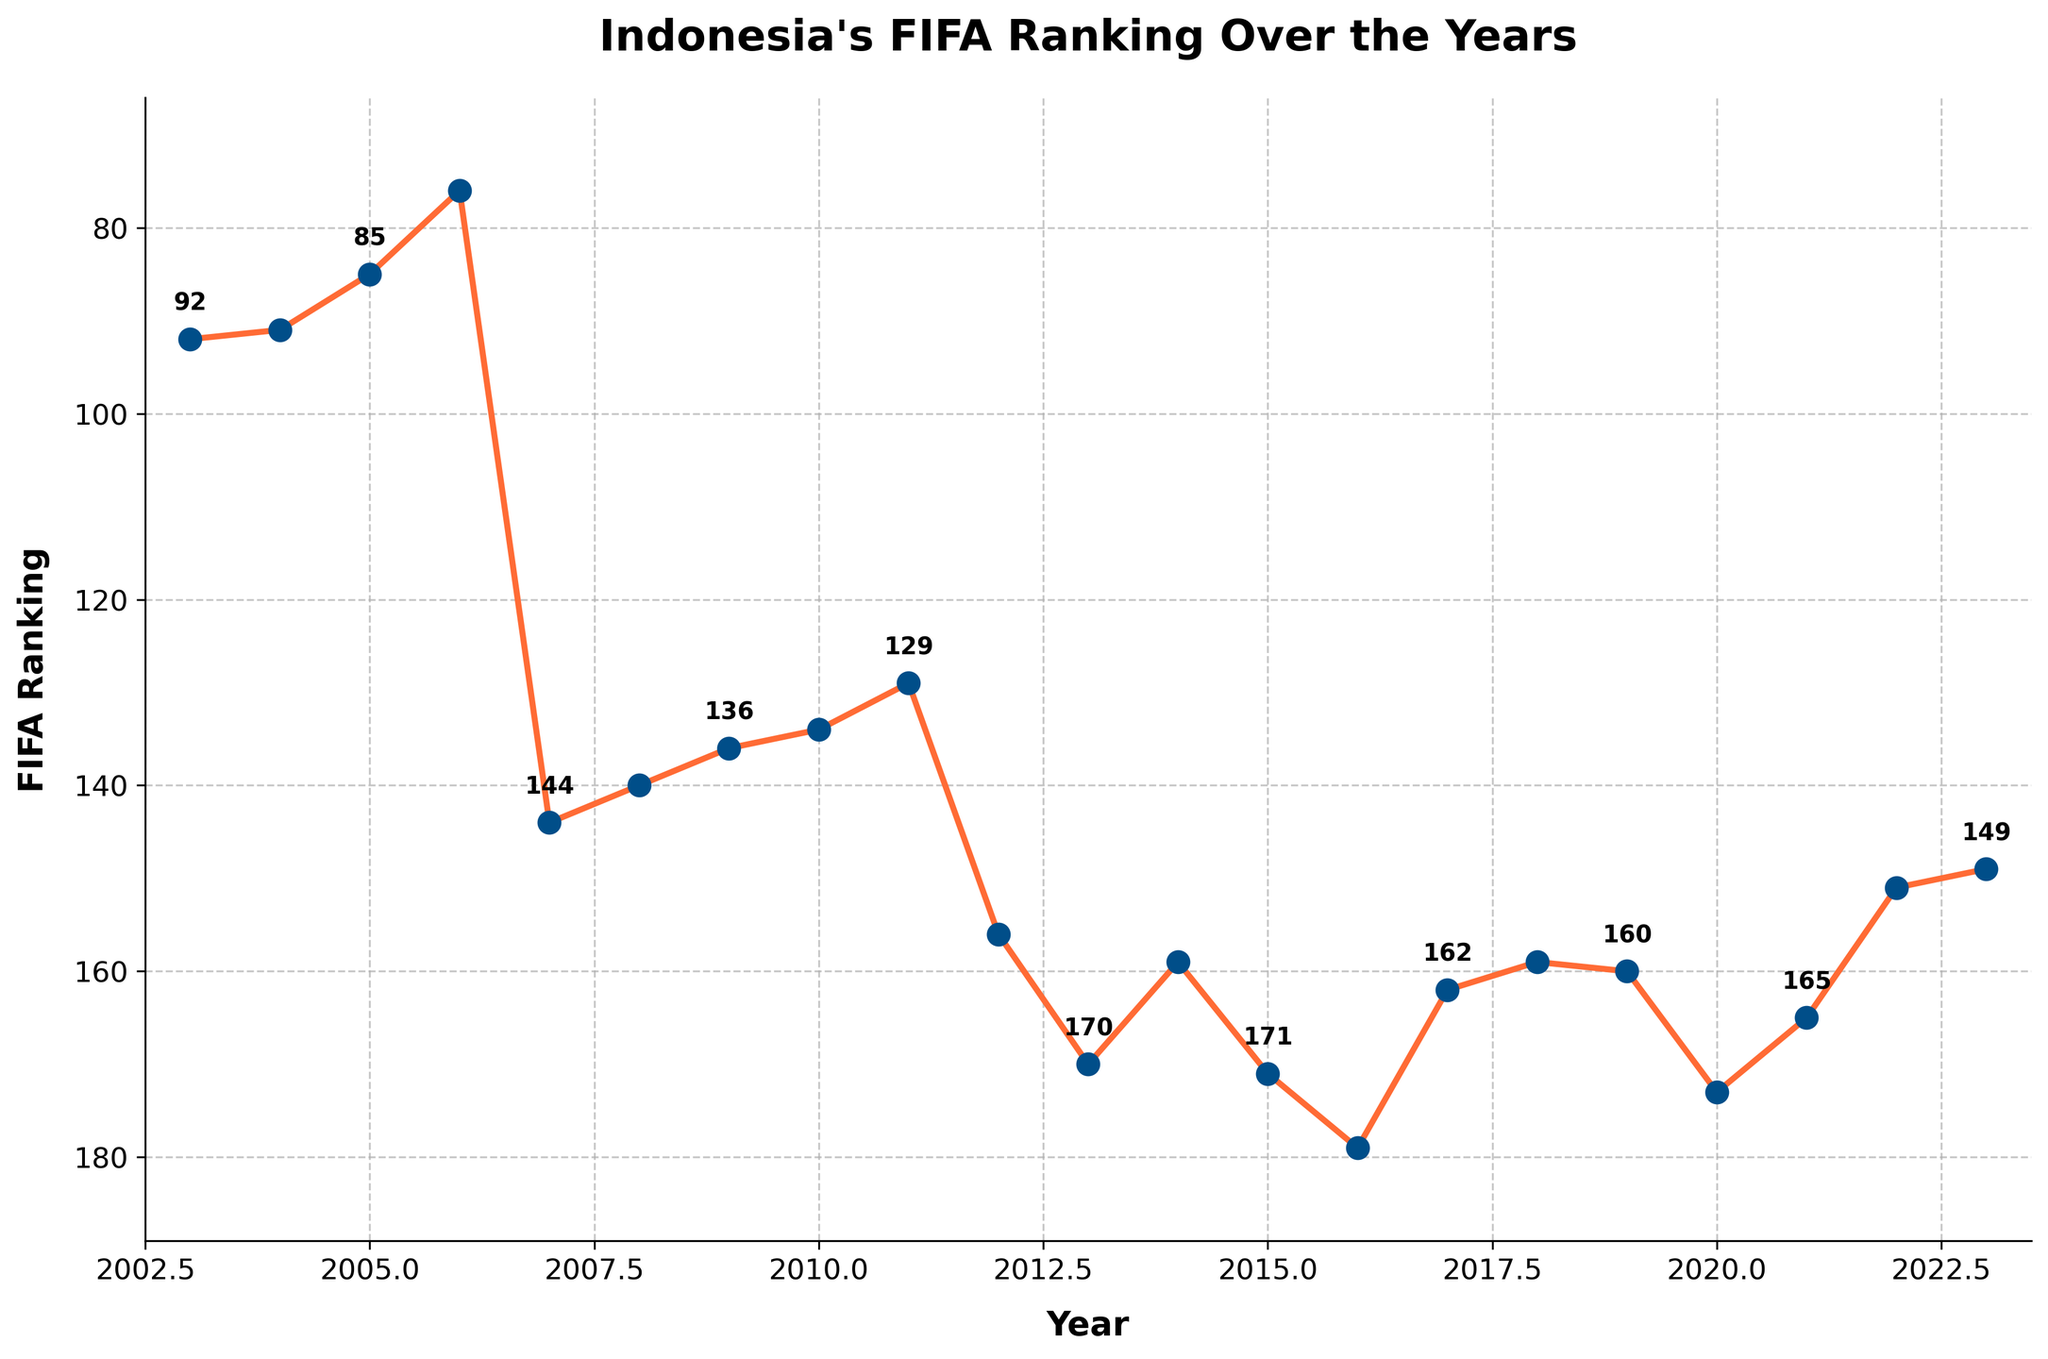Which year has the lowest FIFA ranking? Examine the y-axis values and locate the point in the plot that has the highest value (since higher rank number indicates lower rank). The year 2016 has the lowest FIFA ranking of 179.
Answer: 2016 How did the ranking change from 2006 to 2007? Find the ranking for the years 2006 and 2007 on the plot. The ranking dropped significantly from 76 in 2006 to 144 in 2007.
Answer: Dropped Which two consecutive years show the most significant improvement in ranking? Compare the differences between rankings for each pair of consecutive years. The largest improvement is from 2021 (165) to 2022 (151), a change of 14 ranks.
Answer: 2021 to 2022 What was the average FIFA ranking for Indonesia between 2010 and 2020 inclusive? Sum the rankings for each year from 2010 to 2020 and divide by the number of years (11 years). (134+129+156+170+159+171+179+162+159+160+173) / 11 = 162
Answer: 162 During which period did Indonesia experience a constant decline in ranking? Scan through the plot to identify periods where the ranking consistently gets worse (higher rank number). From 2003 to 2016, the ranking dropped steadily from 92 to 179.
Answer: 2003-2016 What was the ranking difference between the best and worst years? Identify the highest and lowest values in the ranking series. The best was in 2006 (76) and the worst was in 2016 (179). The difference is 179 - 76 = 103.
Answer: 103 Which year saw the steepest decline in ranking compared to its previous year? Calculate the year-to-year differences and find the maximum negative change. From 2006 (76) to 2007 (144), the ranking dropped by 68 ranks, the steepest decline.
Answer: 2007 What is the trend in Indonesia's FIFA ranking from 2015 to 2023? Observe the plot from 2015 to 2023. The ranking undergoes minor fluctuations but improves overall from 171 in 2015 to 149 in 2023.
Answer: Improving How does the ranking in 2023 compare to that in 2003? Compare the FIFA rankings for 2023 (149) and 2003 (92). The ranking in 2023 is worse by 57 ranks.
Answer: Worse by 57 